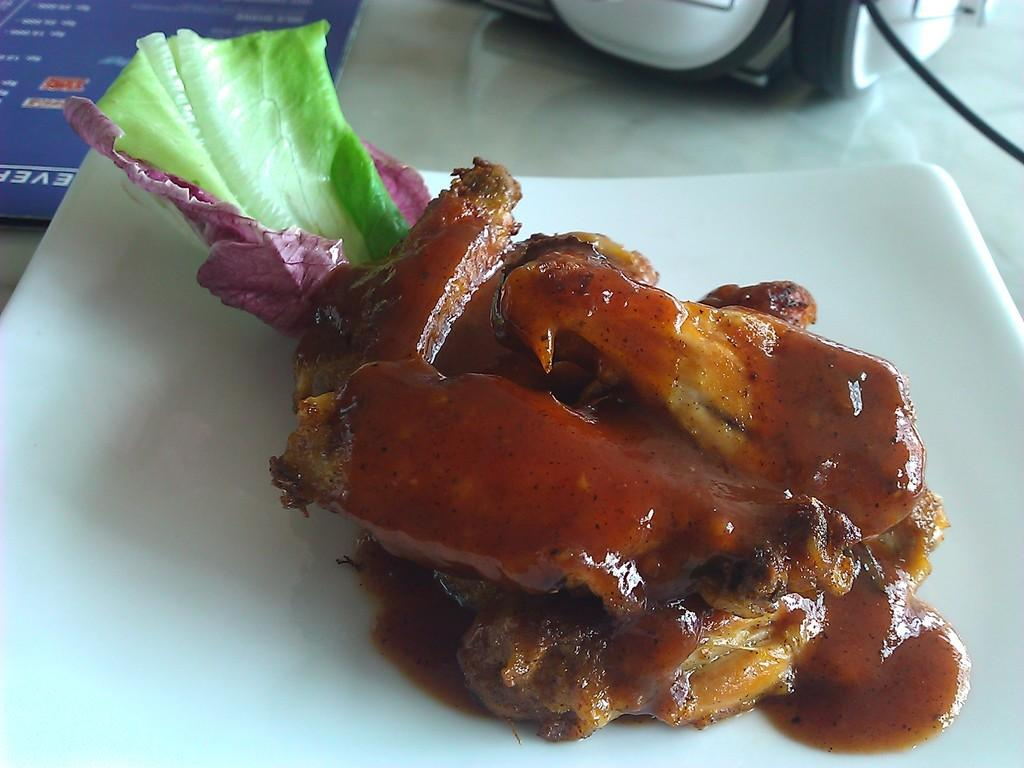What is on the plate that is visible in the image? There is a plate with food in the image. What can be seen in the top left corner of the image? There is a menu card in the top left of the image. What is located in the top right corner of the image? There are headphones in the top right of the image. What type of bread is being used to control the headphones in the image? There is no bread present in the image, and the headphones are not being controlled by any object. 